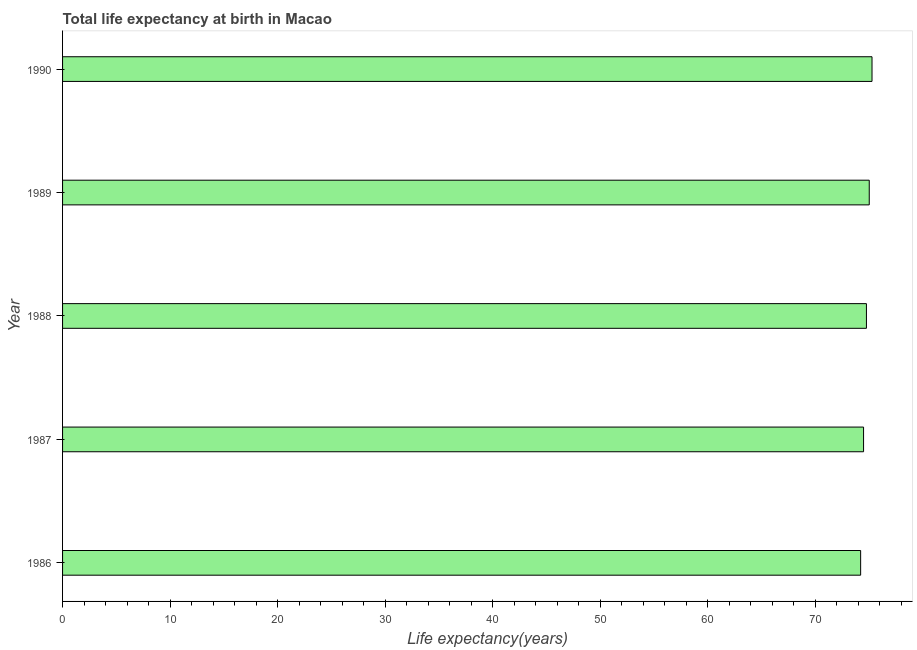Does the graph contain grids?
Give a very brief answer. No. What is the title of the graph?
Provide a succinct answer. Total life expectancy at birth in Macao. What is the label or title of the X-axis?
Your answer should be very brief. Life expectancy(years). What is the label or title of the Y-axis?
Provide a succinct answer. Year. What is the life expectancy at birth in 1987?
Keep it short and to the point. 74.49. Across all years, what is the maximum life expectancy at birth?
Keep it short and to the point. 75.28. Across all years, what is the minimum life expectancy at birth?
Your answer should be compact. 74.22. In which year was the life expectancy at birth maximum?
Your response must be concise. 1990. What is the sum of the life expectancy at birth?
Ensure brevity in your answer.  373.76. What is the difference between the life expectancy at birth in 1986 and 1987?
Your response must be concise. -0.27. What is the average life expectancy at birth per year?
Provide a succinct answer. 74.75. What is the median life expectancy at birth?
Your answer should be very brief. 74.76. In how many years, is the life expectancy at birth greater than 28 years?
Your answer should be compact. 5. Is the life expectancy at birth in 1986 less than that in 1988?
Make the answer very short. Yes. Is the difference between the life expectancy at birth in 1988 and 1989 greater than the difference between any two years?
Offer a terse response. No. What is the difference between the highest and the second highest life expectancy at birth?
Provide a succinct answer. 0.26. Is the sum of the life expectancy at birth in 1987 and 1988 greater than the maximum life expectancy at birth across all years?
Ensure brevity in your answer.  Yes. What is the difference between the highest and the lowest life expectancy at birth?
Provide a succinct answer. 1.06. In how many years, is the life expectancy at birth greater than the average life expectancy at birth taken over all years?
Keep it short and to the point. 3. How many years are there in the graph?
Provide a short and direct response. 5. What is the difference between two consecutive major ticks on the X-axis?
Provide a short and direct response. 10. Are the values on the major ticks of X-axis written in scientific E-notation?
Your response must be concise. No. What is the Life expectancy(years) in 1986?
Offer a very short reply. 74.22. What is the Life expectancy(years) in 1987?
Offer a very short reply. 74.49. What is the Life expectancy(years) of 1988?
Offer a very short reply. 74.76. What is the Life expectancy(years) in 1989?
Your answer should be very brief. 75.02. What is the Life expectancy(years) of 1990?
Offer a terse response. 75.28. What is the difference between the Life expectancy(years) in 1986 and 1987?
Your answer should be very brief. -0.27. What is the difference between the Life expectancy(years) in 1986 and 1988?
Your answer should be very brief. -0.54. What is the difference between the Life expectancy(years) in 1986 and 1989?
Provide a succinct answer. -0.8. What is the difference between the Life expectancy(years) in 1986 and 1990?
Provide a succinct answer. -1.06. What is the difference between the Life expectancy(years) in 1987 and 1988?
Provide a succinct answer. -0.27. What is the difference between the Life expectancy(years) in 1987 and 1989?
Make the answer very short. -0.53. What is the difference between the Life expectancy(years) in 1987 and 1990?
Your response must be concise. -0.79. What is the difference between the Life expectancy(years) in 1988 and 1989?
Offer a very short reply. -0.26. What is the difference between the Life expectancy(years) in 1988 and 1990?
Your answer should be compact. -0.52. What is the difference between the Life expectancy(years) in 1989 and 1990?
Provide a short and direct response. -0.26. What is the ratio of the Life expectancy(years) in 1986 to that in 1987?
Make the answer very short. 1. What is the ratio of the Life expectancy(years) in 1986 to that in 1988?
Offer a very short reply. 0.99. What is the ratio of the Life expectancy(years) in 1986 to that in 1989?
Give a very brief answer. 0.99. 